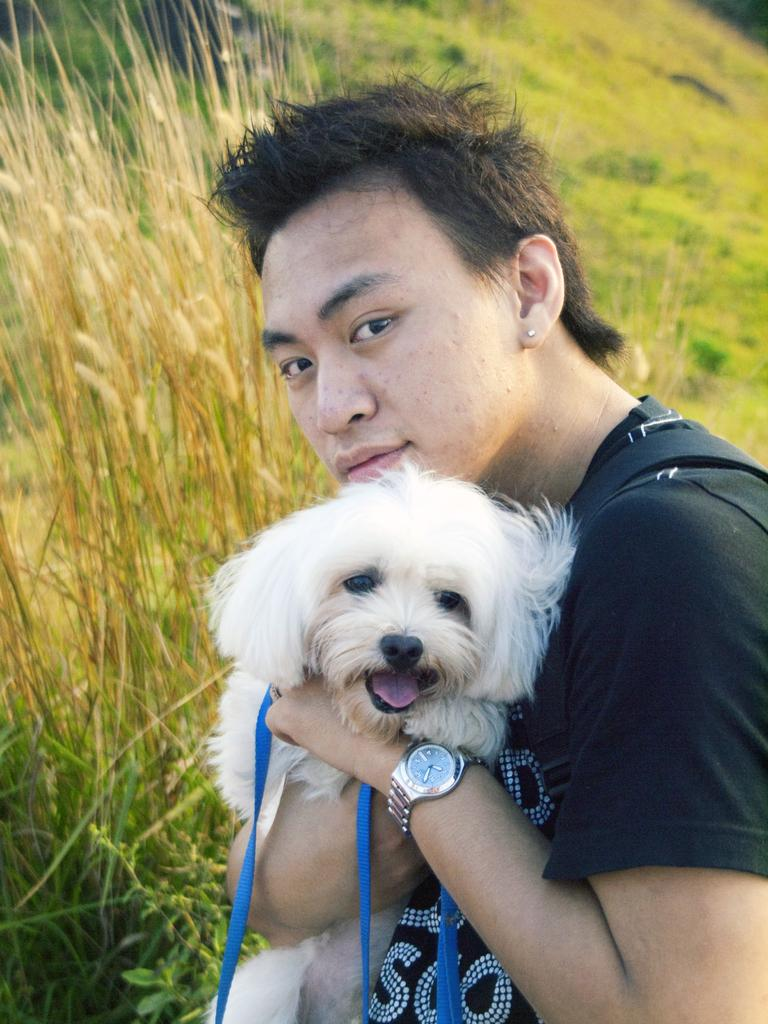What is the person in the image doing? The person is holding a dog in the image. What can be observed about the person's clothing? The person is wearing a black shirt. What is the color of the dog being held by the person? The dog is white in color. What type of environment is visible in the background? The background consists of grass. Can you describe the colors of the grass in the image? The grass has brown and green colors. What is the tendency of the loaf in the image? There is no loaf present in the image. 